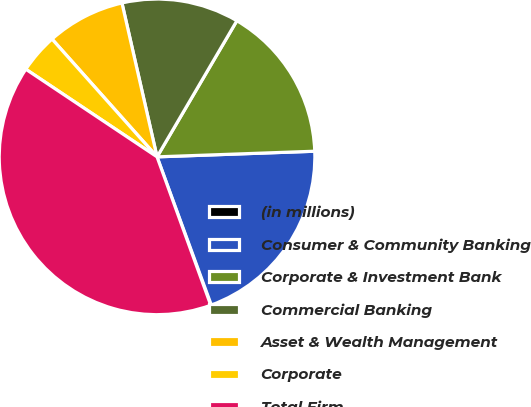Convert chart. <chart><loc_0><loc_0><loc_500><loc_500><pie_chart><fcel>(in millions)<fcel>Consumer & Community Banking<fcel>Corporate & Investment Bank<fcel>Commercial Banking<fcel>Asset & Wealth Management<fcel>Corporate<fcel>Total Firm<nl><fcel>0.06%<fcel>19.98%<fcel>15.99%<fcel>12.01%<fcel>8.02%<fcel>4.04%<fcel>39.9%<nl></chart> 